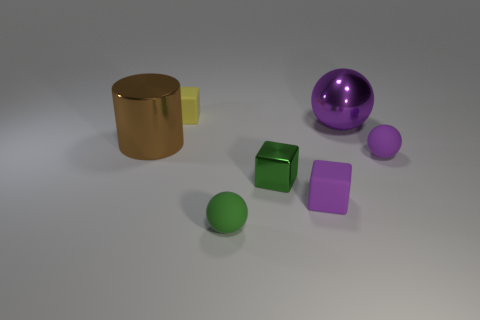Add 2 tiny purple matte spheres. How many objects exist? 9 Subtract all cylinders. How many objects are left? 6 Subtract all green spheres. Subtract all purple metal balls. How many objects are left? 5 Add 7 purple matte balls. How many purple matte balls are left? 8 Add 2 tiny cyan matte cylinders. How many tiny cyan matte cylinders exist? 2 Subtract 0 blue balls. How many objects are left? 7 